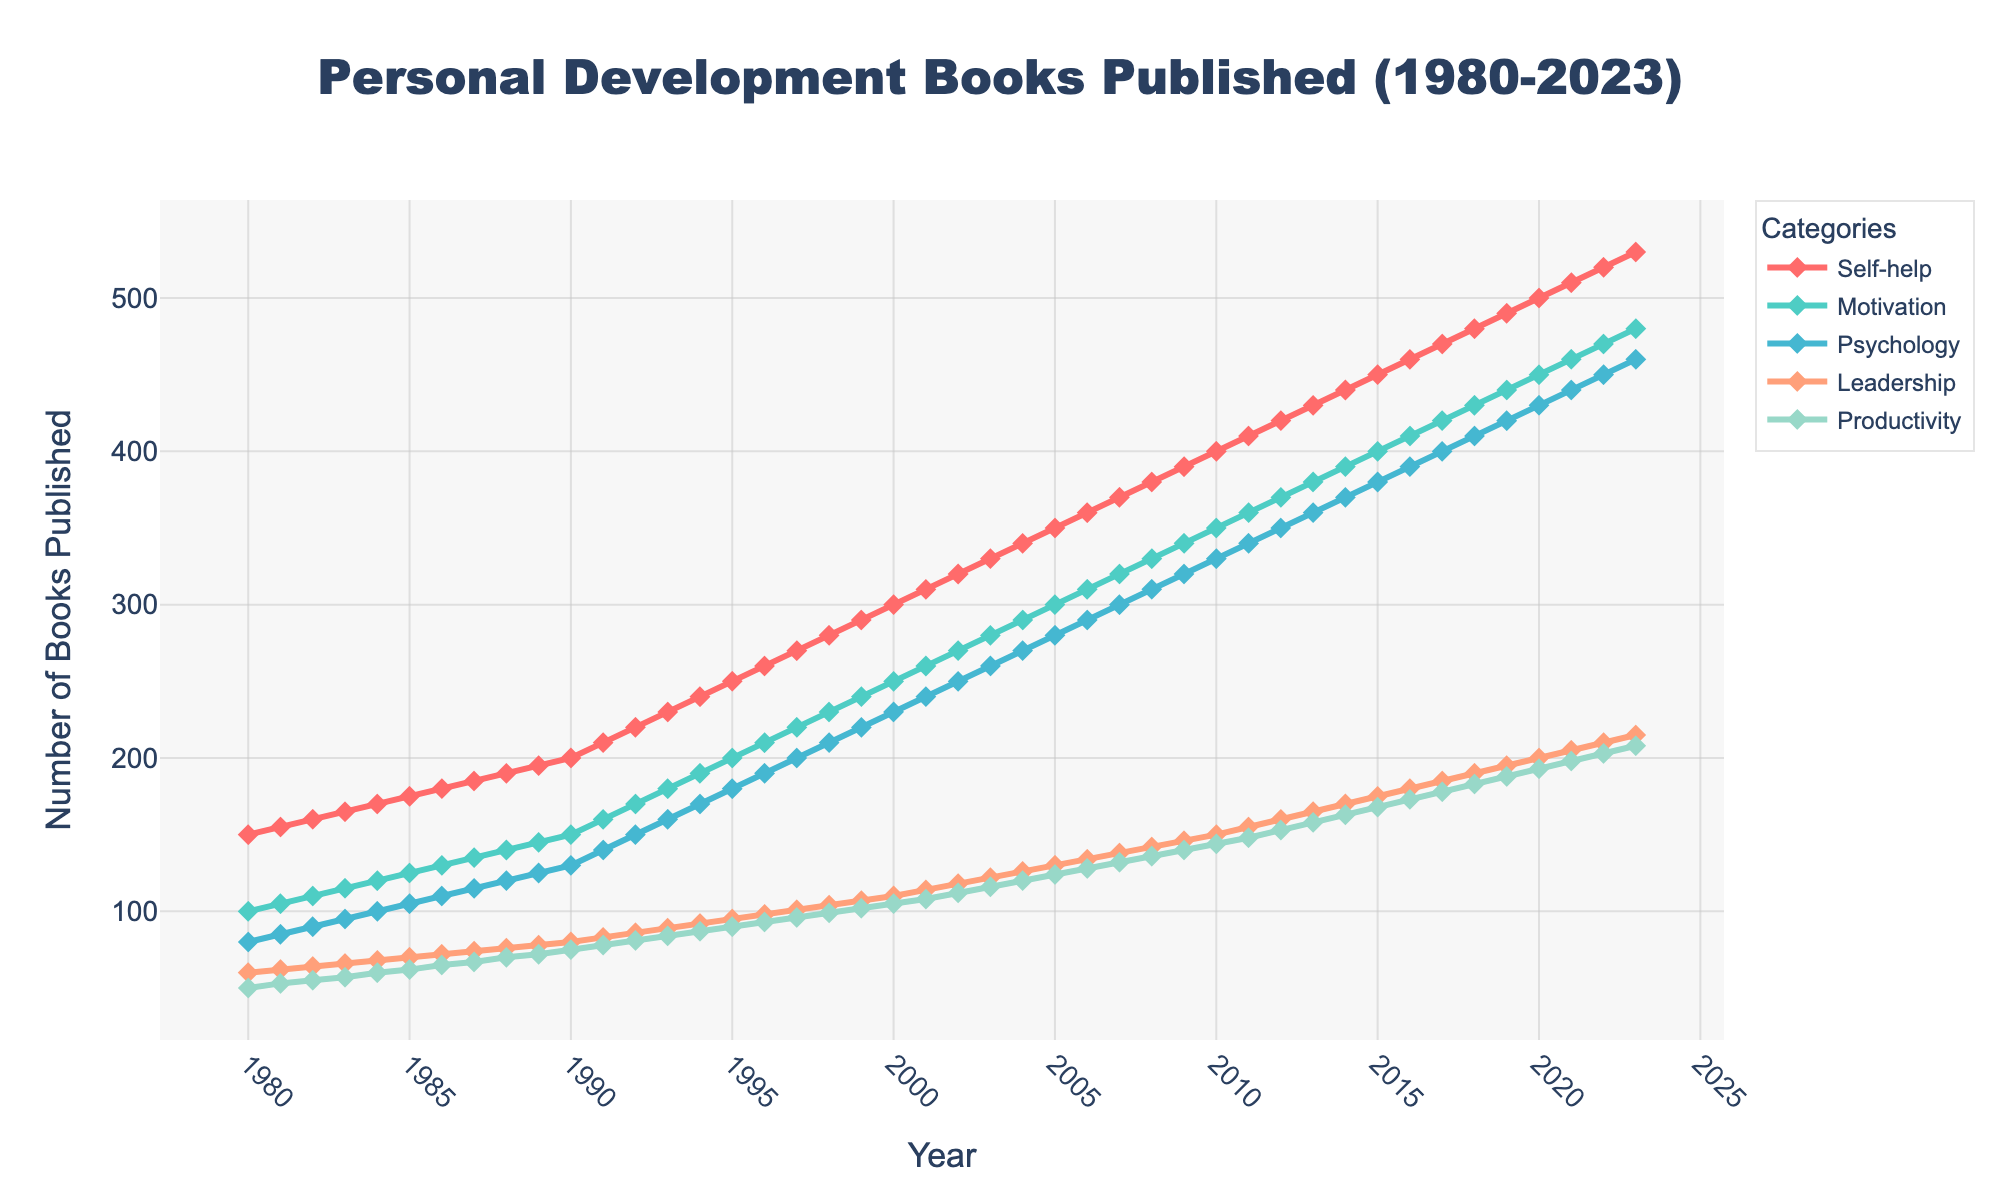What is the title of the figure? The title of the figure usually appears at the top and provides a summary of the content. Here, it is written in large, bold letters.
Answer: Personal Development Books Published (1980-2023) Which category has the highest number of books published in 2023? Look at the value for the year 2023 for each category on the y-axis. The category with the highest value is the one with the highest number of books.
Answer: Self-help What is the trend for the "Leadership" category from 1980 to 2023? Follow the line representing "Leadership" from 1980 to 2023 and observe whether it generally increases, decreases, or stays the same.
Answer: Increasing Which year saw the most significant increase in the number of "Motivation" books published compared to the previous year? Check the "Motivation" category line for the largest gap between two consecutive points, which indicates the most significant increase.
Answer: 1990 How many "Psychology" books were published in 1995? Find the point on the "Psychology" line corresponding to the year 1995 and read its value on the y-axis.
Answer: 180 What is the difference in the number of "Self-help" and "Productivity" books published in 2020? Find the value for both categories in the year 2020 and subtract the number of "Productivity" books from the number of "Self-help" books.
Answer: 307 Which category shows the smallest growth from 1980 to 2023? Calculate the difference in the number of books for each category between 1980 and 2023. The category with the smallest difference shows the smallest growth.
Answer: Productivity How many categories are represented in the figure? Count the distinct lines in the plot, each representing a different category of books.
Answer: 5 During which period did the "Self-help" category show the most consistent growth? Observe the "Self-help" category line and identify the longest time span where the line increases steadily without sudden jumps or drops.
Answer: 1980-2023 What are the colors used to represent the different categories? Identify the distinctive colors used for each line in the plot, noting the variety and matching them with the categories.
Answer: Red, Teal, Light Blue, Orange, and Light Green 